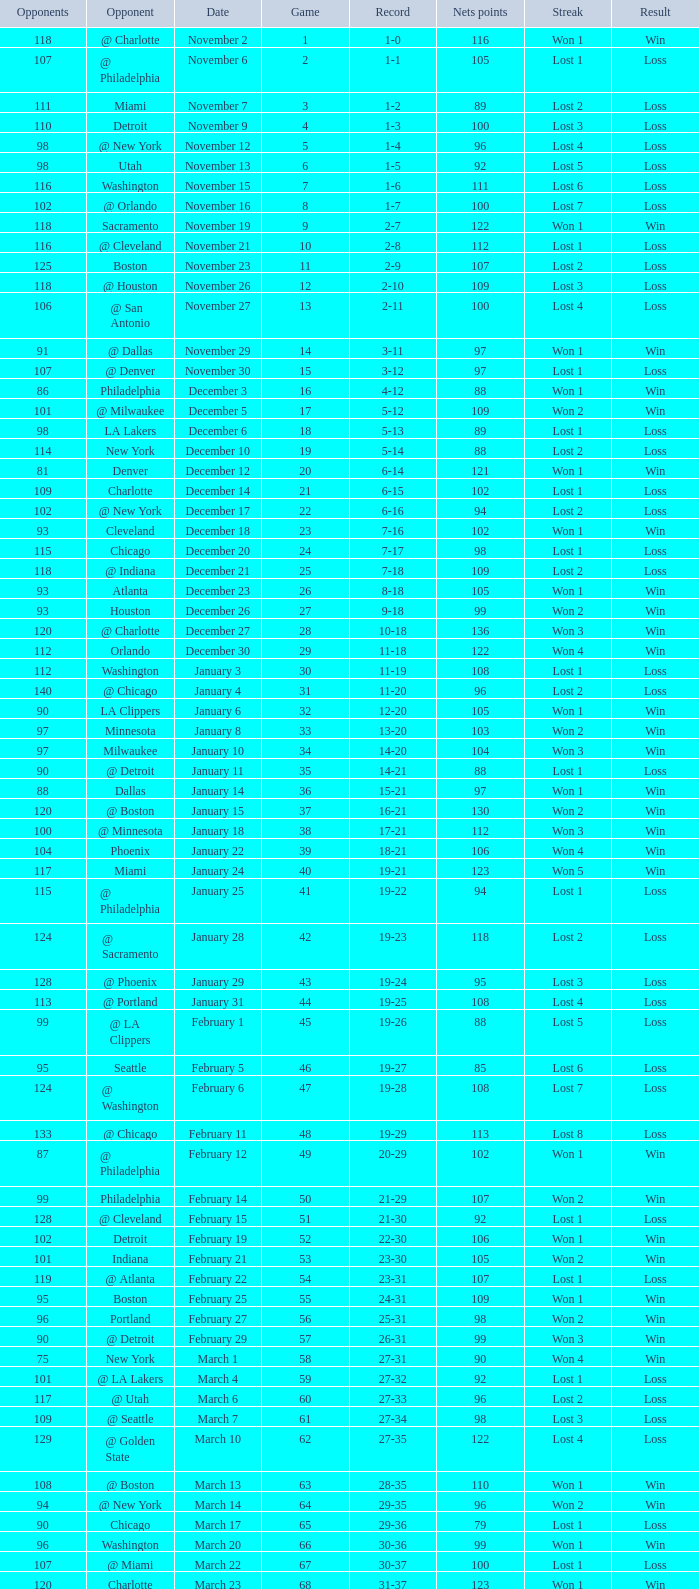How many games had fewer than 118 opponents and more than 109 net points with an opponent of Washington? 1.0. 